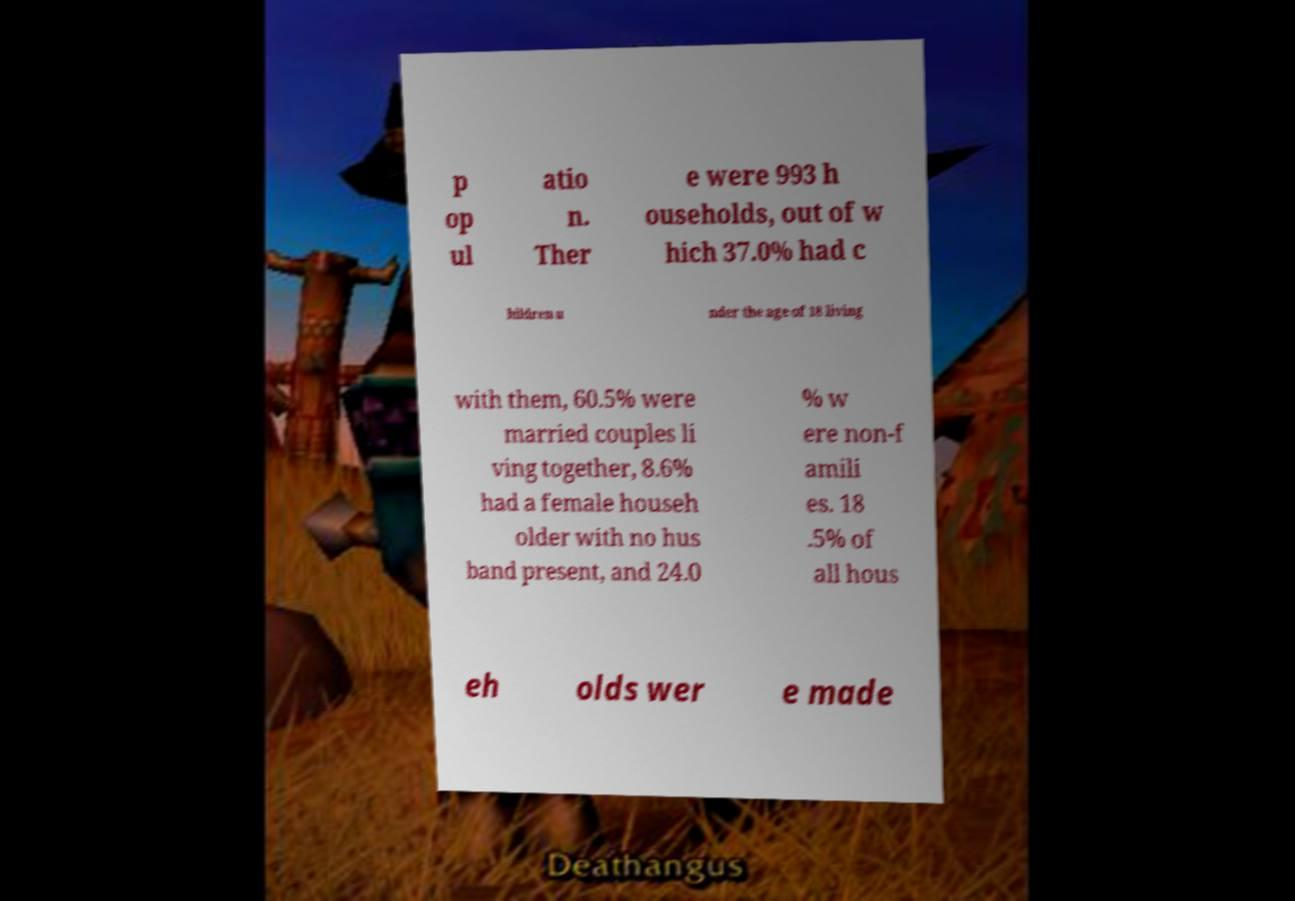Can you accurately transcribe the text from the provided image for me? p op ul atio n. Ther e were 993 h ouseholds, out of w hich 37.0% had c hildren u nder the age of 18 living with them, 60.5% were married couples li ving together, 8.6% had a female househ older with no hus band present, and 24.0 % w ere non-f amili es. 18 .5% of all hous eh olds wer e made 